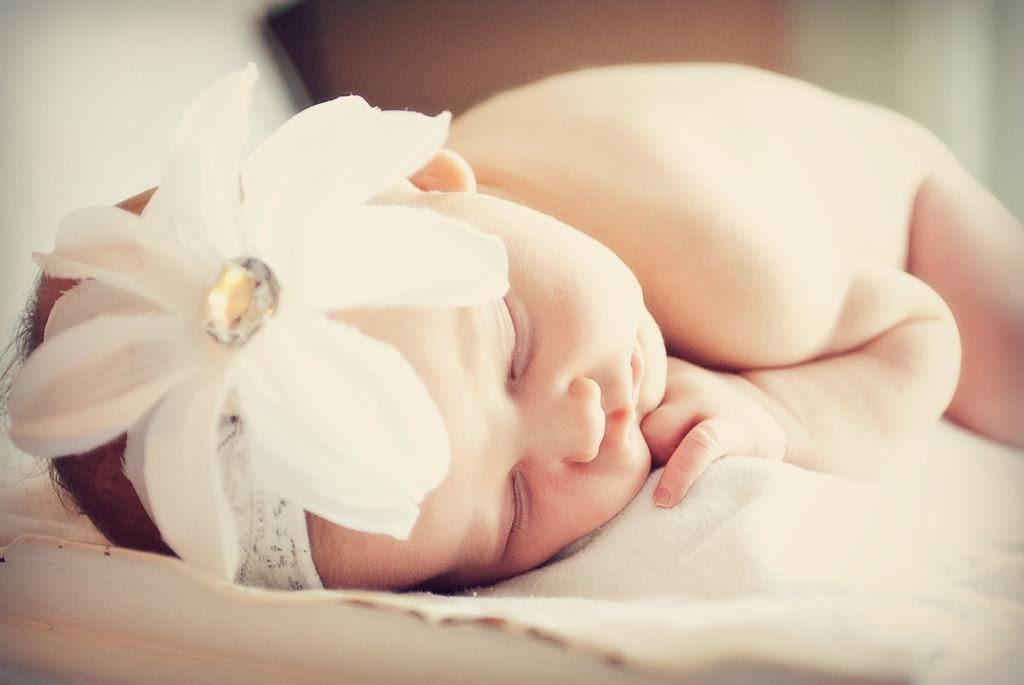What is the main subject of the image? There is a baby in the image. What is the baby lying on? The baby is lying on a cloth. What is the baby wearing on their head? The baby is wearing a wire headband. How would you describe the background of the image? The background of the image is blurry. What nation does the baby rule in the image? There is no indication in the image that the baby is ruling any nation. 